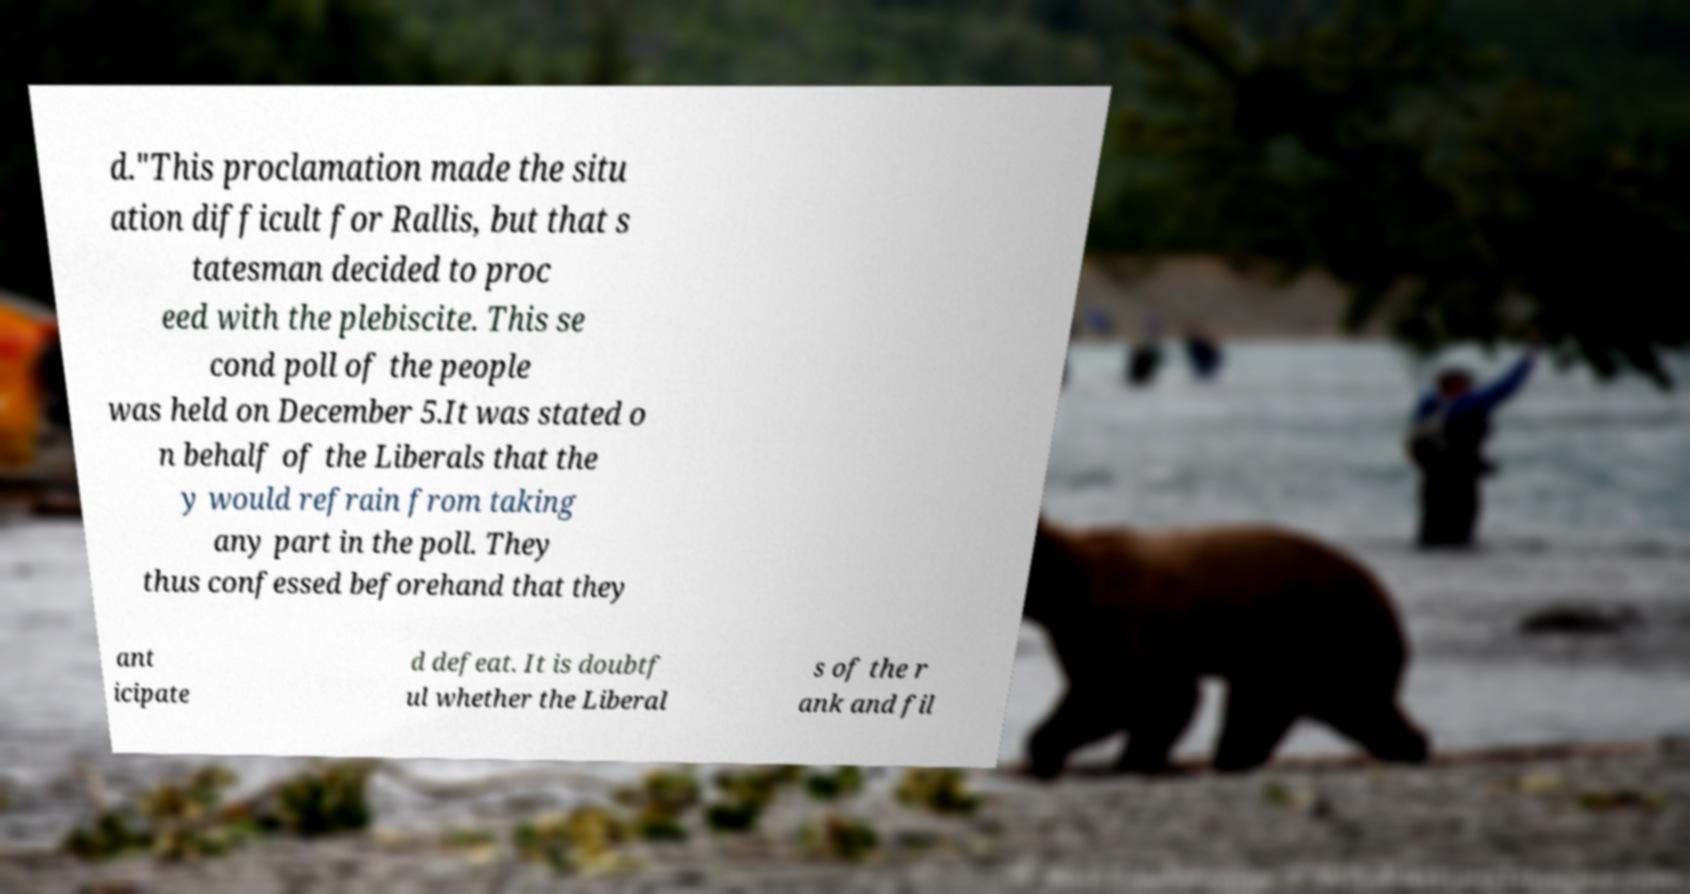I need the written content from this picture converted into text. Can you do that? d."This proclamation made the situ ation difficult for Rallis, but that s tatesman decided to proc eed with the plebiscite. This se cond poll of the people was held on December 5.It was stated o n behalf of the Liberals that the y would refrain from taking any part in the poll. They thus confessed beforehand that they ant icipate d defeat. It is doubtf ul whether the Liberal s of the r ank and fil 